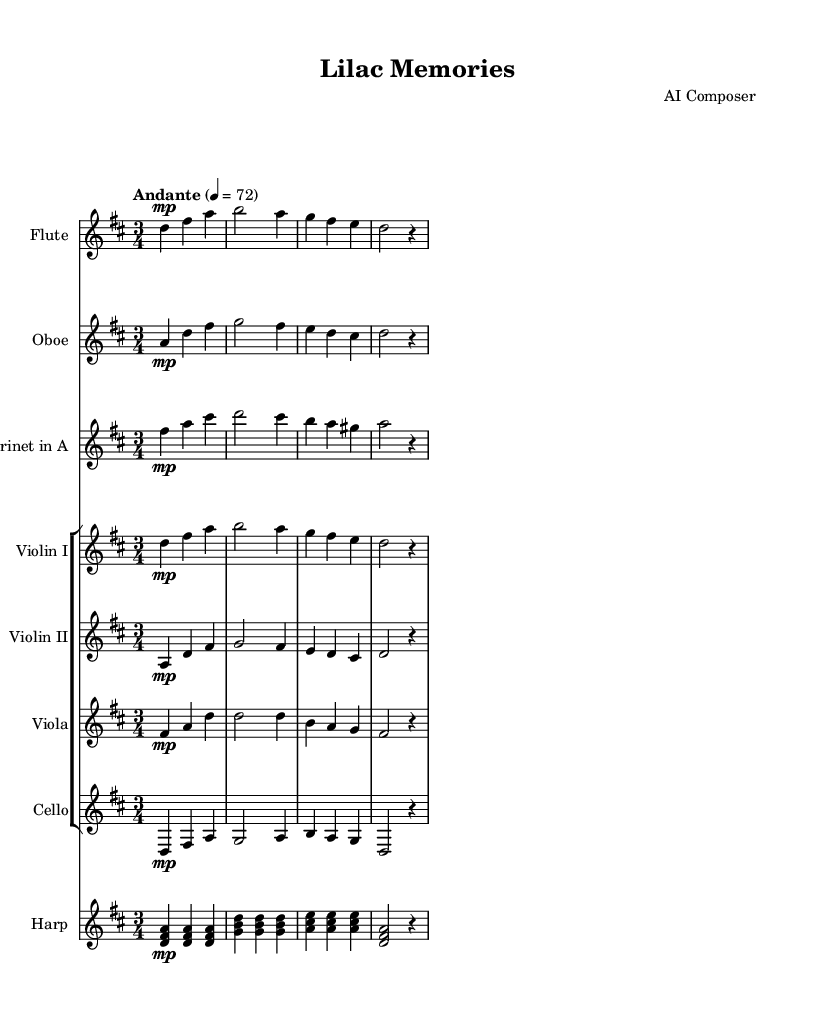What is the key signature of this music? The key signature shows two sharps, which indicate that the key is D major.
Answer: D major What is the time signature of this piece? The time signature is indicated by the fraction at the beginning of the score, in this case, it shows three beats per measure, indicating a waltz or ternary feel.
Answer: 3/4 What is the tempo marking for this piece? The tempo marking is located above the score, indicating a gentle speed of 72 beats per minute with "Andante," which means moderately slow.
Answer: Andante What instruments are featured in this orchestral piece? By looking at the staves, we can identify that flute, oboe, clarinet, two violins, viola, cello, and harp are the instruments included in this score.
Answer: Flute, Oboe, Clarinet, Violin I, Violin II, Viola, Cello, Harp How many measures are in the main sections played by the strings? Each instrument's staff shows a series of notes and rests grouped into measures; counting those reveals that there are a total of 16 measures in the strings' repeated sections.
Answer: 16 Which instrument plays the first part of the main theme? By observing the score, the first staff indicates that the flute plays the opening melodic material, establishing the primary motif of the piece.
Answer: Flute 